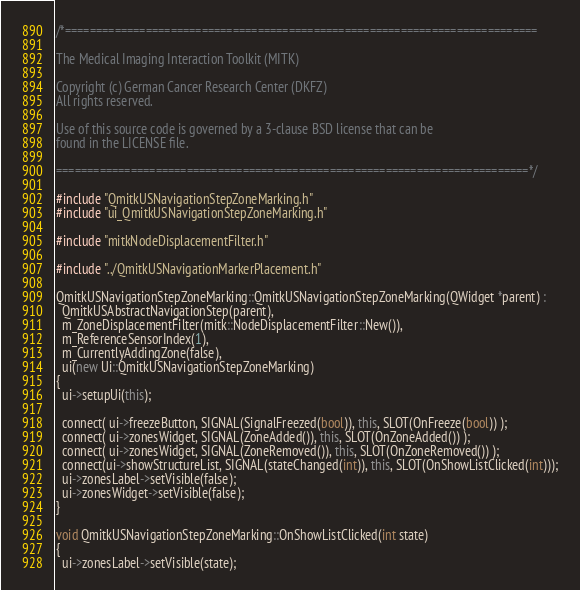<code> <loc_0><loc_0><loc_500><loc_500><_C++_>/*============================================================================

The Medical Imaging Interaction Toolkit (MITK)

Copyright (c) German Cancer Research Center (DKFZ)
All rights reserved.

Use of this source code is governed by a 3-clause BSD license that can be
found in the LICENSE file.

============================================================================*/

#include "QmitkUSNavigationStepZoneMarking.h"
#include "ui_QmitkUSNavigationStepZoneMarking.h"

#include "mitkNodeDisplacementFilter.h"

#include "../QmitkUSNavigationMarkerPlacement.h"

QmitkUSNavigationStepZoneMarking::QmitkUSNavigationStepZoneMarking(QWidget *parent) :
  QmitkUSAbstractNavigationStep(parent),
  m_ZoneDisplacementFilter(mitk::NodeDisplacementFilter::New()),
  m_ReferenceSensorIndex(1),
  m_CurrentlyAddingZone(false),
  ui(new Ui::QmitkUSNavigationStepZoneMarking)
{
  ui->setupUi(this);

  connect( ui->freezeButton, SIGNAL(SignalFreezed(bool)), this, SLOT(OnFreeze(bool)) );
  connect( ui->zonesWidget, SIGNAL(ZoneAdded()), this, SLOT(OnZoneAdded()) );
  connect( ui->zonesWidget, SIGNAL(ZoneRemoved()), this, SLOT(OnZoneRemoved()) );
  connect(ui->showStructureList, SIGNAL(stateChanged(int)), this, SLOT(OnShowListClicked(int)));
  ui->zonesLabel->setVisible(false);
  ui->zonesWidget->setVisible(false);
}

void QmitkUSNavigationStepZoneMarking::OnShowListClicked(int state)
{
  ui->zonesLabel->setVisible(state);</code> 